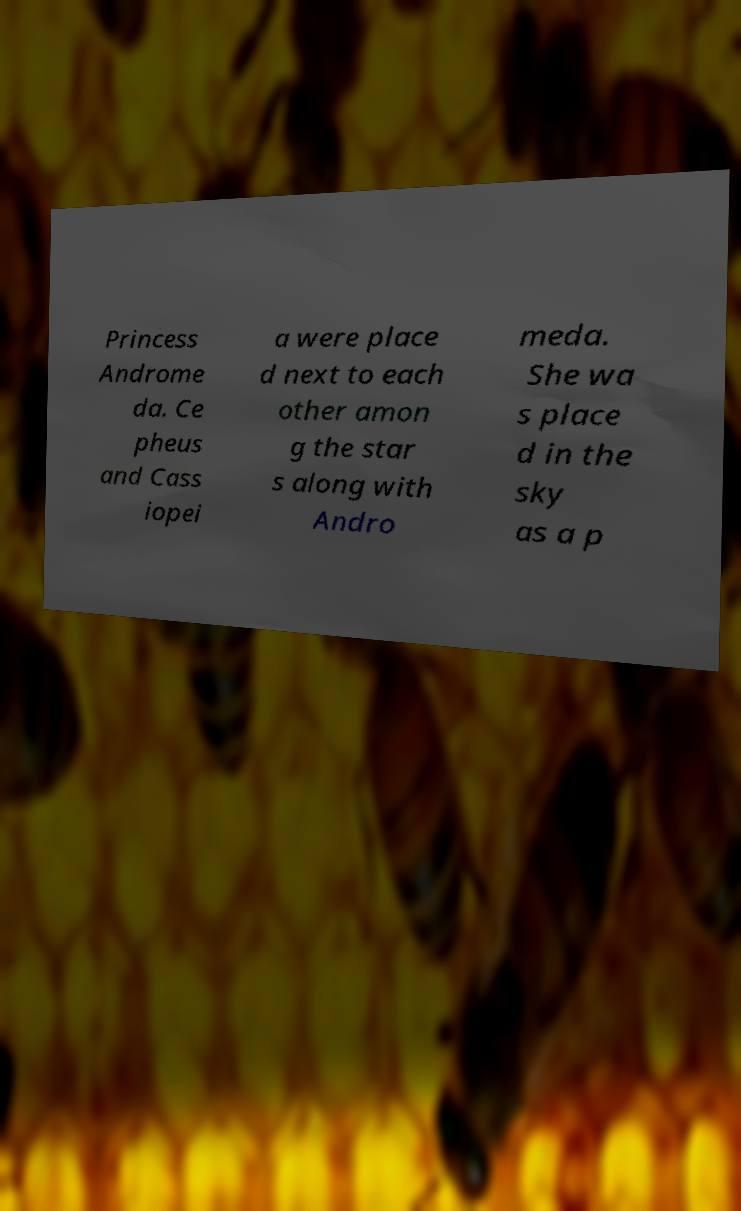What messages or text are displayed in this image? I need them in a readable, typed format. Princess Androme da. Ce pheus and Cass iopei a were place d next to each other amon g the star s along with Andro meda. She wa s place d in the sky as a p 